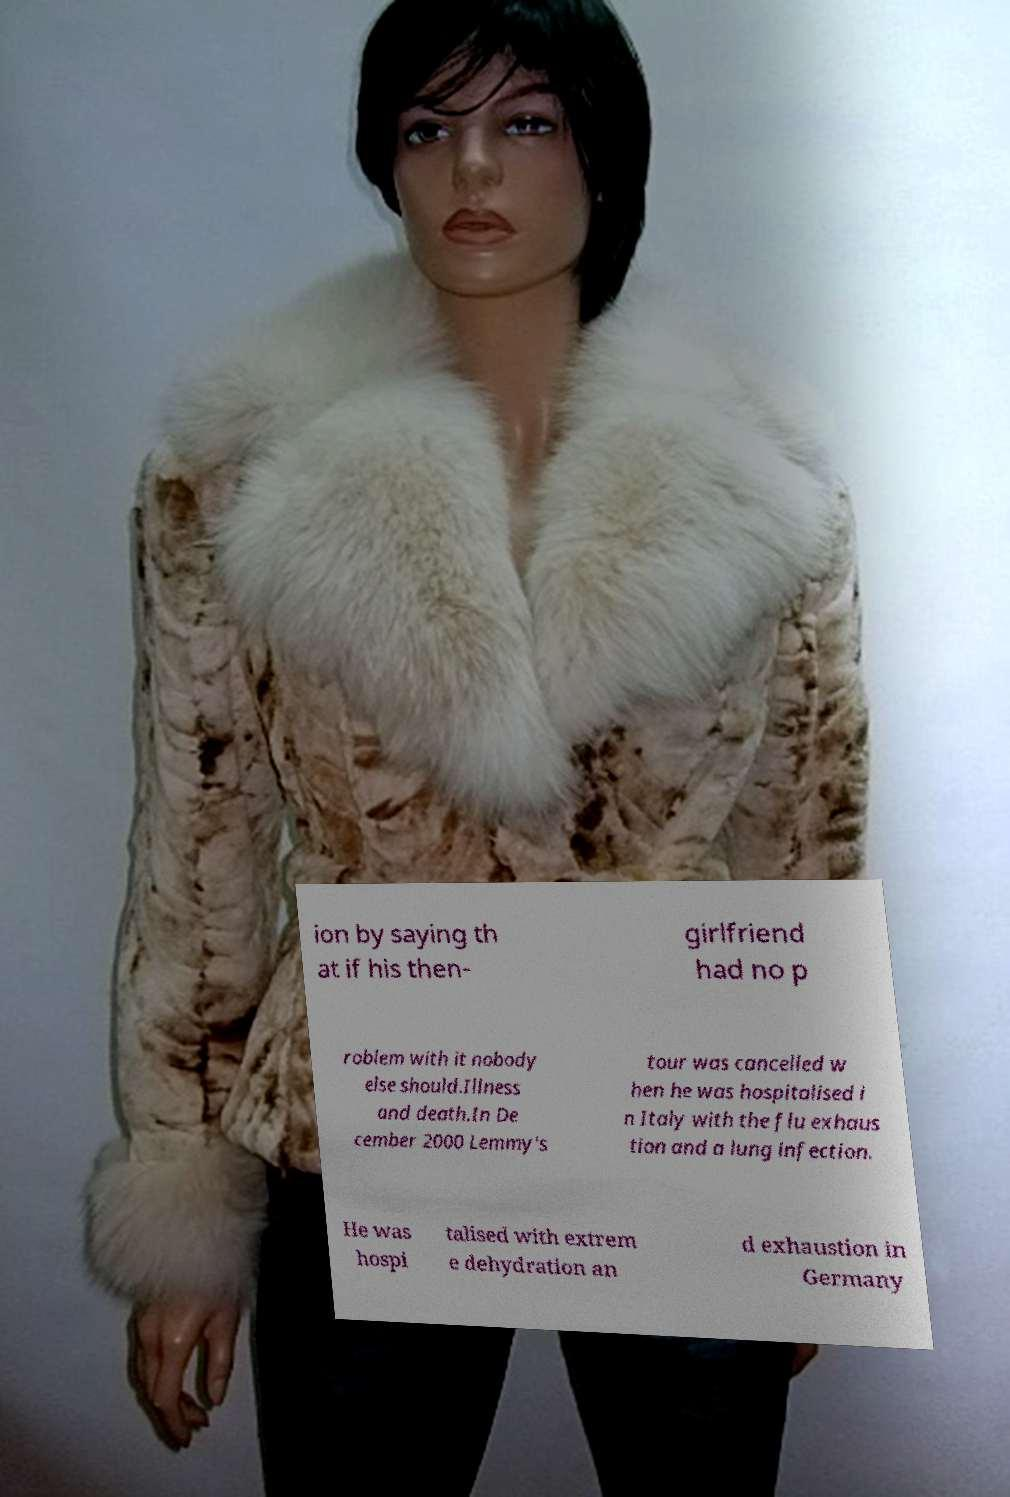Please identify and transcribe the text found in this image. ion by saying th at if his then- girlfriend had no p roblem with it nobody else should.Illness and death.In De cember 2000 Lemmy's tour was cancelled w hen he was hospitalised i n Italy with the flu exhaus tion and a lung infection. He was hospi talised with extrem e dehydration an d exhaustion in Germany 